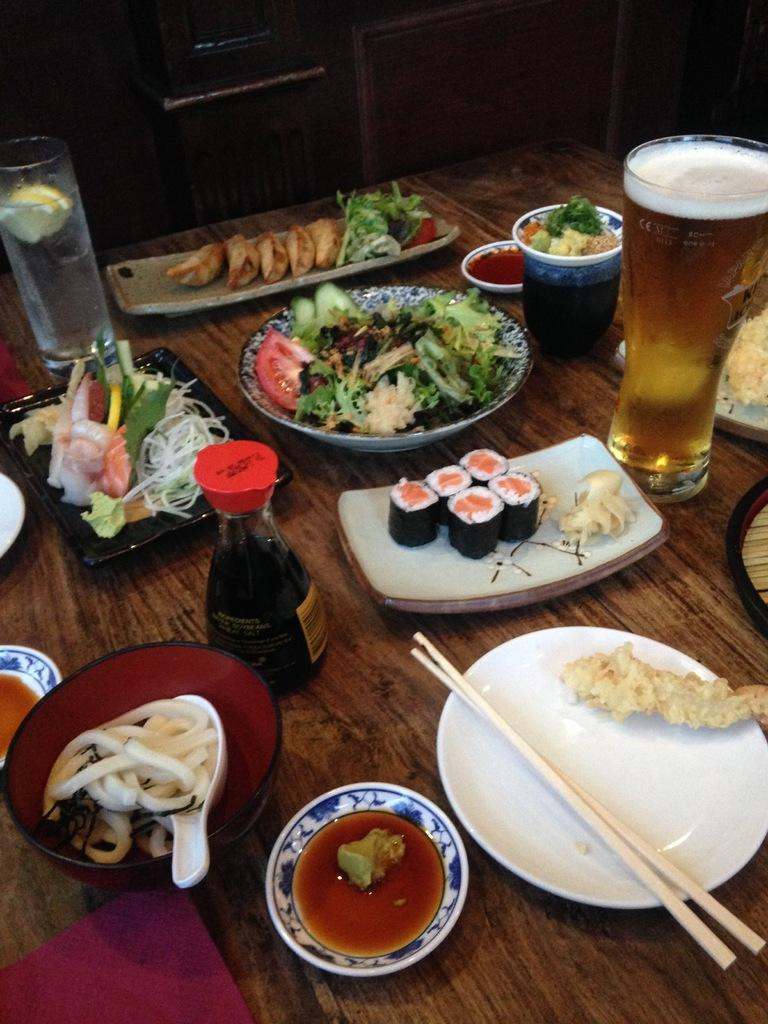How many glasses can be seen in the image? There are two glasses in the image. What other tableware is present in the image? There are plates and cups in the image. Are there any other objects on the table in the image? Yes, there are other objects on the table in the image. How many bats are hanging from the chandelier in the image? There are no bats or chandelier present in the image. What type of jewel can be seen on the table in the image? There is no jewel present on the table in the image. 